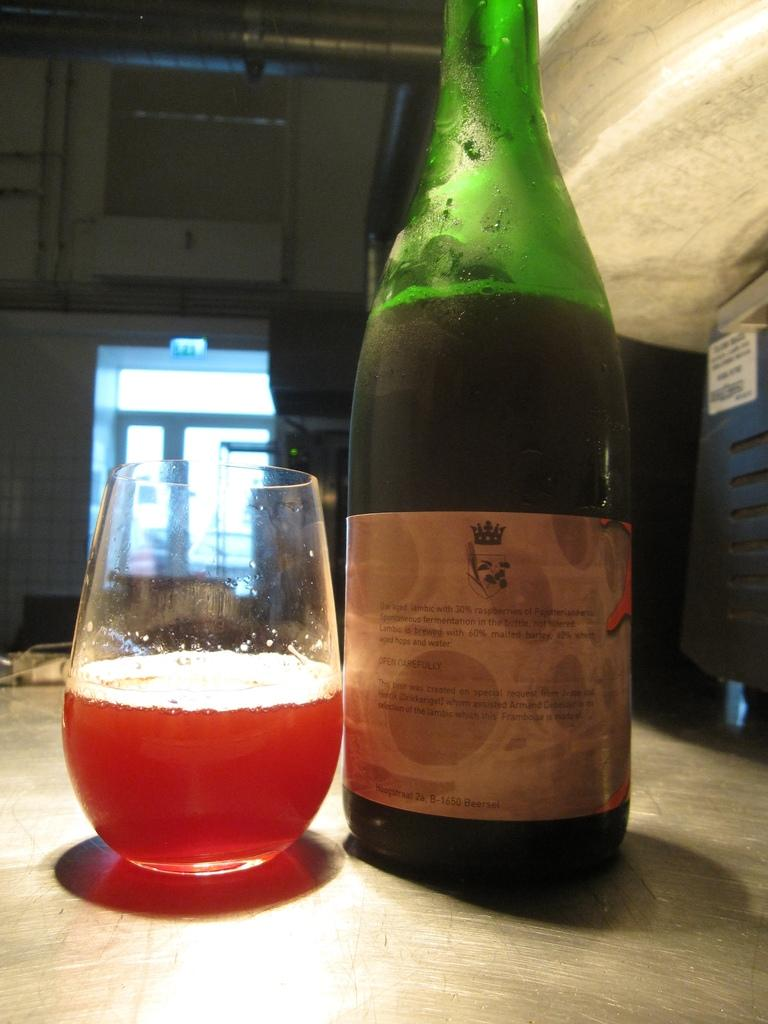What object can be seen in the image that is used for holding liquids? There is a bottle in the image that is used for holding liquids. What is the color of the bottle in the image? The bottle is green in color. What other object can be seen in the image that is also used for holding liquids? There is a glass in the image that is used for holding liquids. What is the color of the liquid in the glass? The liquid in the glass is red. What type of scent can be smelled coming from the bottle in the image? There is no information about the scent of the liquid in the bottle, as the facts provided only mention the color of the bottle and the glass. 